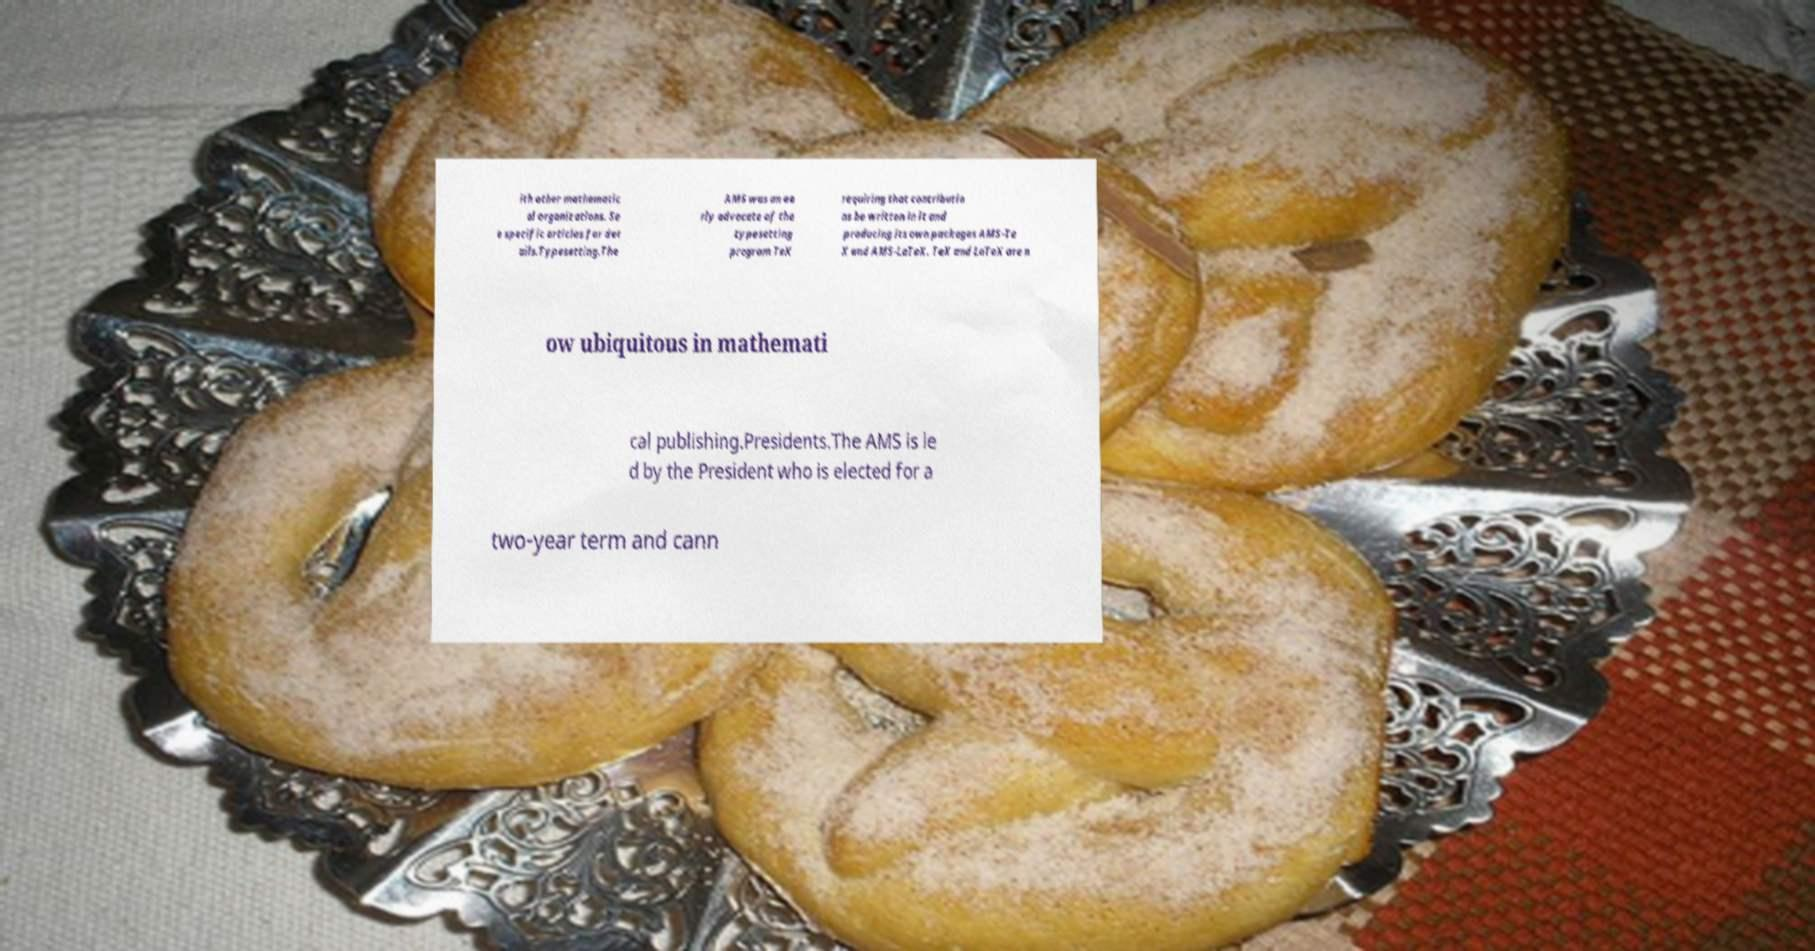Please identify and transcribe the text found in this image. ith other mathematic al organizations. Se e specific articles for det ails.Typesetting.The AMS was an ea rly advocate of the typesetting program TeX requiring that contributio ns be written in it and producing its own packages AMS-Te X and AMS-LaTeX. TeX and LaTeX are n ow ubiquitous in mathemati cal publishing.Presidents.The AMS is le d by the President who is elected for a two-year term and cann 